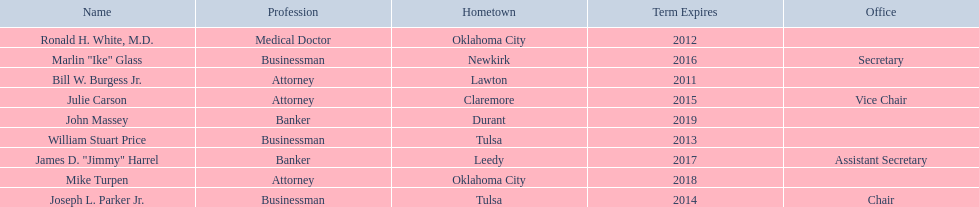Which regents are from tulsa? William Stuart Price, Joseph L. Parker Jr. Which of these is not joseph parker, jr.? William Stuart Price. 